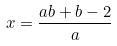<formula> <loc_0><loc_0><loc_500><loc_500>x = \frac { a b + b - 2 } { a }</formula> 